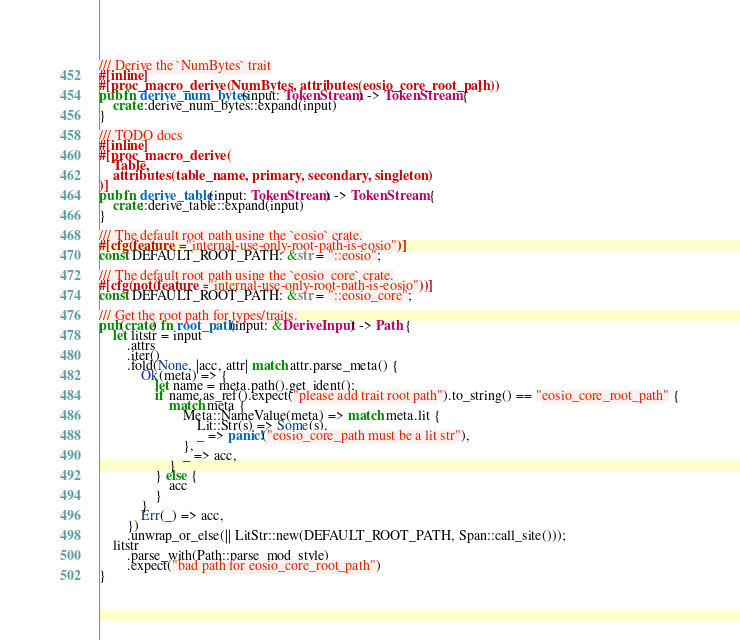Convert code to text. <code><loc_0><loc_0><loc_500><loc_500><_Rust_>
/// Derive the `NumBytes` trait
#[inline]
#[proc_macro_derive(NumBytes, attributes(eosio_core_root_path))]
pub fn derive_num_bytes(input: TokenStream) -> TokenStream {
    crate::derive_num_bytes::expand(input)
}

/// TODO docs
#[inline]
#[proc_macro_derive(
    Table,
    attributes(table_name, primary, secondary, singleton)
)]
pub fn derive_table(input: TokenStream) -> TokenStream {
    crate::derive_table::expand(input)
}

/// The default root path using the `eosio` crate.
#[cfg(feature = "internal-use-only-root-path-is-eosio")]
const DEFAULT_ROOT_PATH: &str = "::eosio";

/// The default root path using the `eosio_core` crate.
#[cfg(not(feature = "internal-use-only-root-path-is-eosio"))]
const DEFAULT_ROOT_PATH: &str = "::eosio_core";

/// Get the root path for types/traits.
pub(crate) fn root_path(input: &DeriveInput) -> Path {
    let litstr = input
        .attrs
        .iter()
        .fold(None, |acc, attr| match attr.parse_meta() {
            Ok(meta) => {
                let name = meta.path().get_ident();
                if name.as_ref().expect("please add trait root path").to_string() == "eosio_core_root_path" {
                    match meta {
                        Meta::NameValue(meta) => match meta.lit {
                            Lit::Str(s) => Some(s),
                            _ => panic!("eosio_core_path must be a lit str"),
                        },
                        _ => acc,
                    }
                } else {
                    acc
                }
            }
            Err(_) => acc,
        })
        .unwrap_or_else(|| LitStr::new(DEFAULT_ROOT_PATH, Span::call_site()));
    litstr
        .parse_with(Path::parse_mod_style)
        .expect("bad path for eosio_core_root_path")
}
</code> 